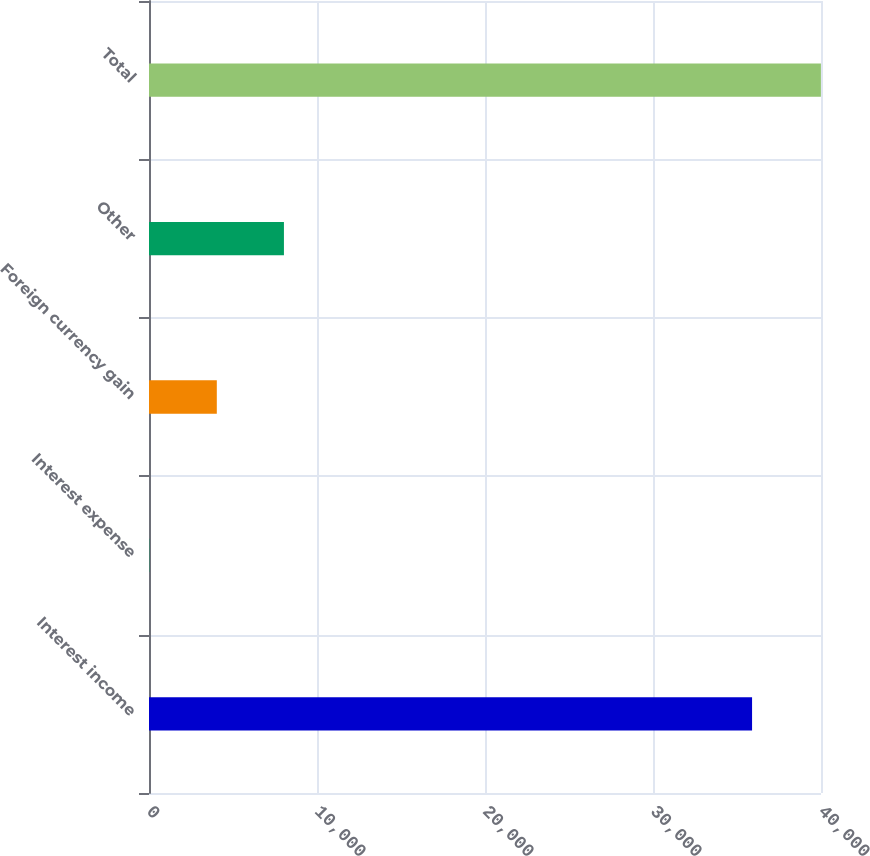Convert chart. <chart><loc_0><loc_0><loc_500><loc_500><bar_chart><fcel>Interest income<fcel>Interest expense<fcel>Foreign currency gain<fcel>Other<fcel>Total<nl><fcel>35897<fcel>41<fcel>4036.4<fcel>8031.8<fcel>39995<nl></chart> 